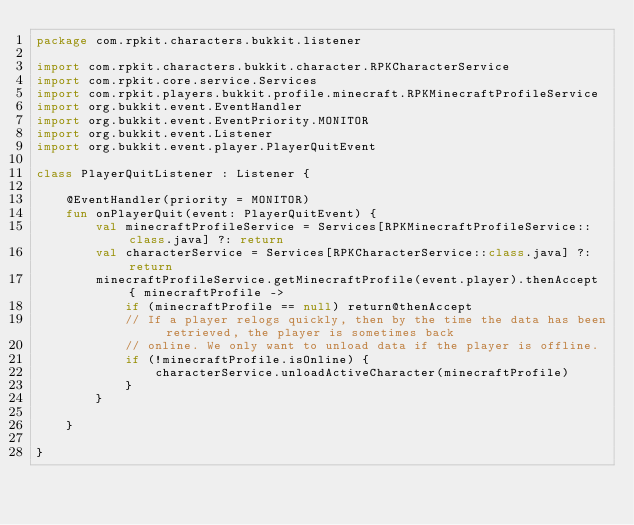Convert code to text. <code><loc_0><loc_0><loc_500><loc_500><_Kotlin_>package com.rpkit.characters.bukkit.listener

import com.rpkit.characters.bukkit.character.RPKCharacterService
import com.rpkit.core.service.Services
import com.rpkit.players.bukkit.profile.minecraft.RPKMinecraftProfileService
import org.bukkit.event.EventHandler
import org.bukkit.event.EventPriority.MONITOR
import org.bukkit.event.Listener
import org.bukkit.event.player.PlayerQuitEvent

class PlayerQuitListener : Listener {

    @EventHandler(priority = MONITOR)
    fun onPlayerQuit(event: PlayerQuitEvent) {
        val minecraftProfileService = Services[RPKMinecraftProfileService::class.java] ?: return
        val characterService = Services[RPKCharacterService::class.java] ?: return
        minecraftProfileService.getMinecraftProfile(event.player).thenAccept { minecraftProfile ->
            if (minecraftProfile == null) return@thenAccept
            // If a player relogs quickly, then by the time the data has been retrieved, the player is sometimes back
            // online. We only want to unload data if the player is offline.
            if (!minecraftProfile.isOnline) {
                characterService.unloadActiveCharacter(minecraftProfile)
            }
        }

    }

}</code> 